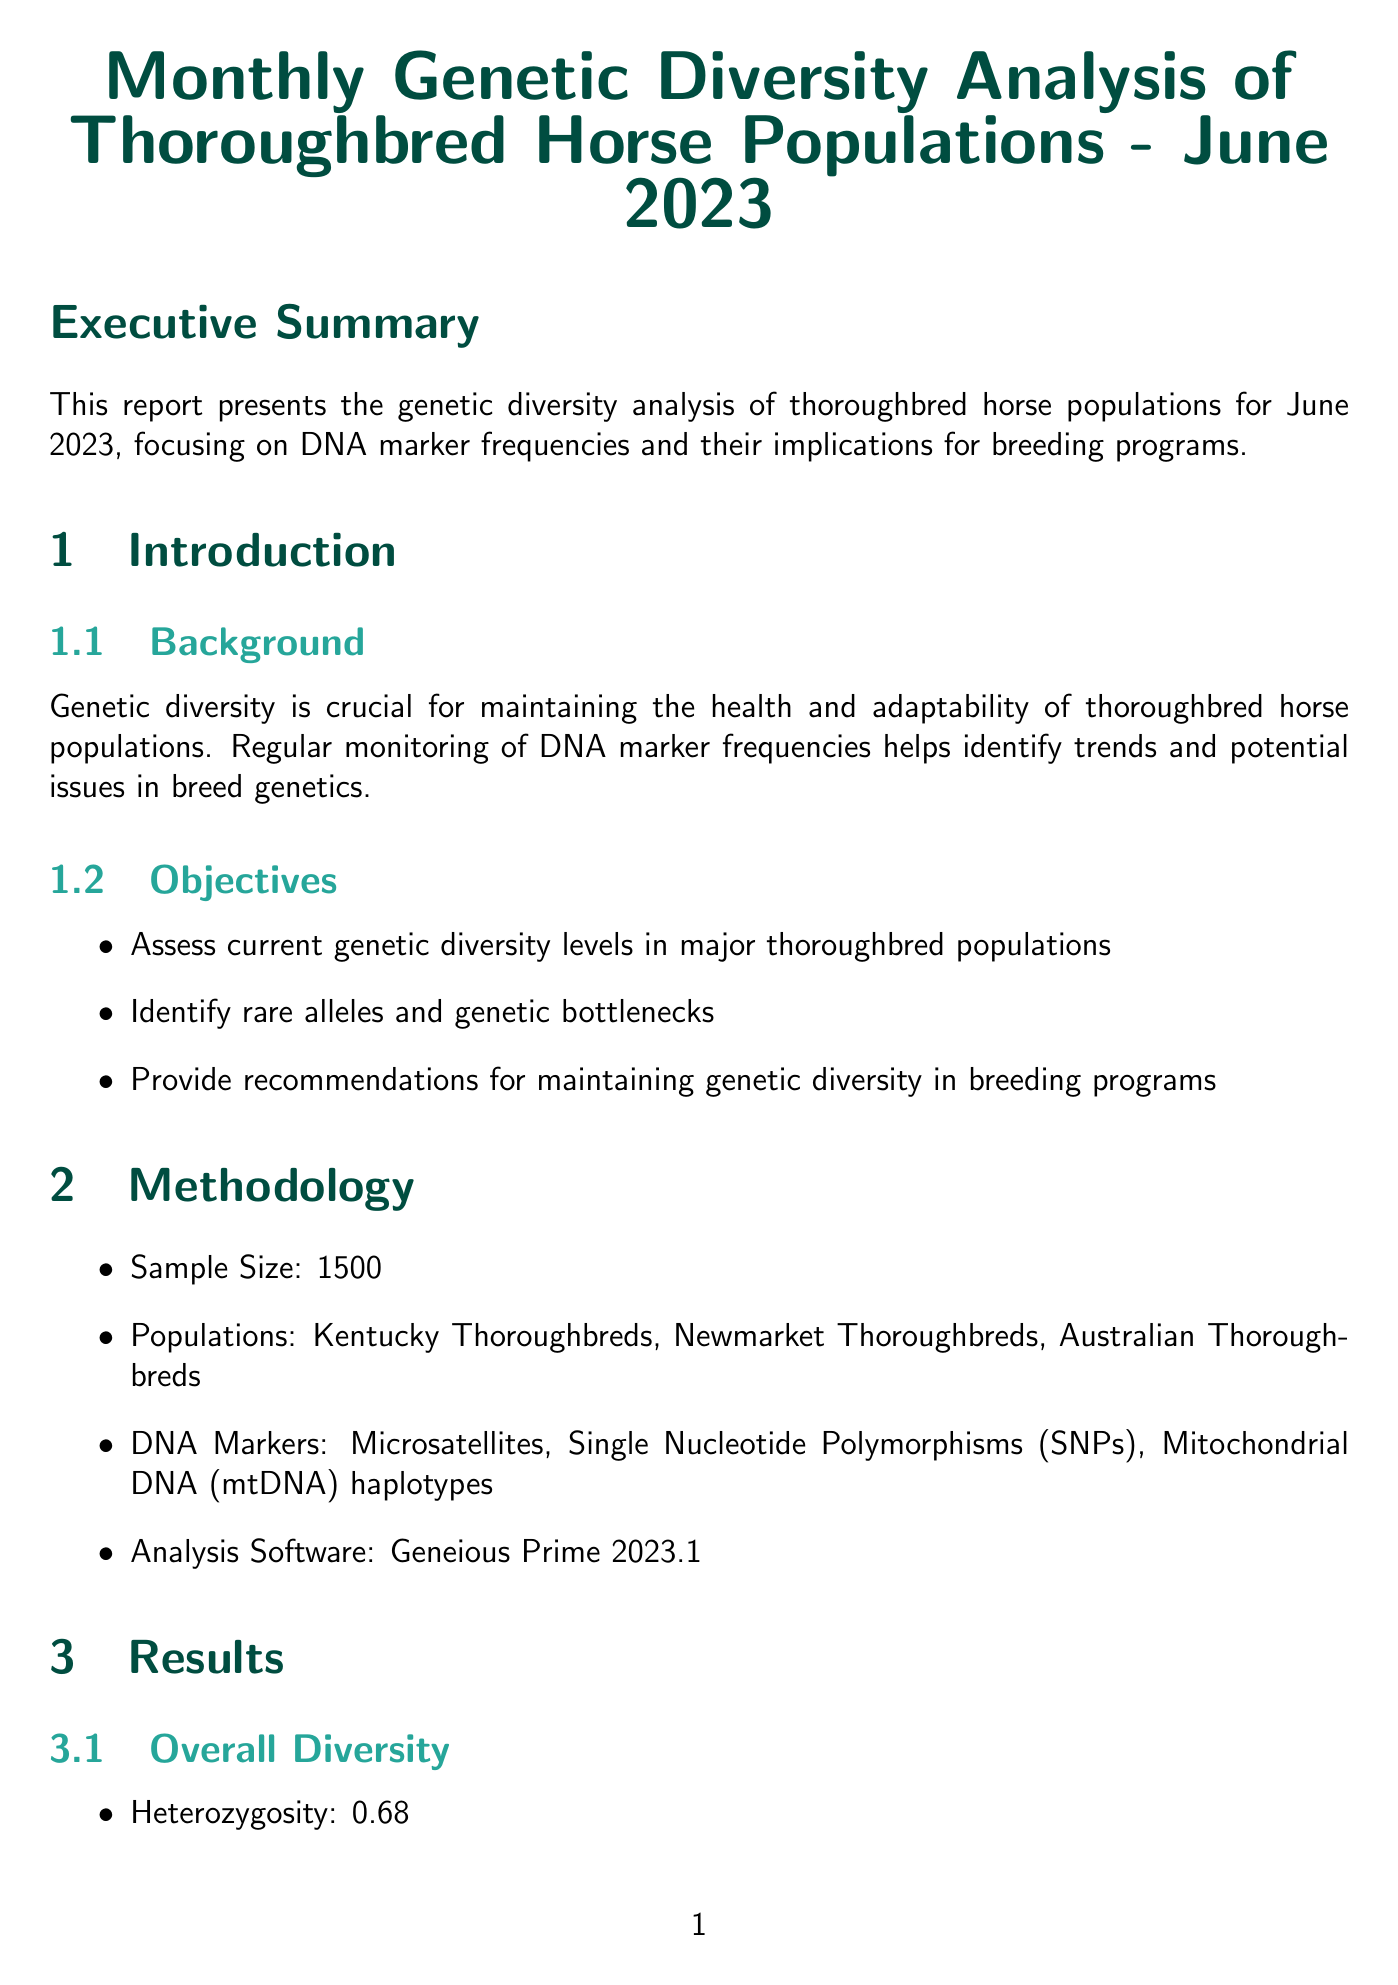What is the sample size of the analysis? The sample size is specified in the methodology section, which states that 1500 horses were sampled for the analysis.
Answer: 1500 What are the three populations analyzed? The populations are listed under the methodology section, where Kentucky Thoroughbreds, Newmarket Thoroughbreds, and Australian Thoroughbreds are mentioned.
Answer: Kentucky Thoroughbreds, Newmarket Thoroughbreds, Australian Thoroughbreds What is the heterozygosity level reported? The overall diversity section reveals that the heterozygosity level is a crucial metric, which is stated as 0.68.
Answer: 0.68 Which thoroughbred population has the highest unique alleles? The population comparisons section indicates that the Australian Thoroughbreds have the highest unique alleles, being noted with a count of 15.
Answer: Australian Thoroughbreds What is the frequency of the rare allele AHT4? The rare alleles section provides frequencies for specific alleles, with the frequency of AHT4 listed as 0.003.
Answer: 0.003 What recommendation is made for the Australian population? The recommendations section highlights targeted breeding strategies to maintain rare alleles, emphasizing actions needed specifically for the Australian population.
Answer: Implement targeted breeding strategies How does the inbreeding coefficient change from the previous analysis? The discussion points note a slight increase in the inbreeding coefficient compared to the last month, mentioning a current figure of 0.023.
Answer: Increase What is the significance of "Galileo's Legacy"? The significant pedigrees section indicates that Galileo's Legacy carries multiple rare alleles and has high breeding value for maintaining genetic diversity, showcasing its importance in the genetic landscape.
Answer: Carries multiple rare alleles What type of visual representation shows genetic relationships among populations? The visualizations section describes a Principal Component Analysis (PCA) plot that visually represents genetic distances among the populations studied based on DNA marker data.
Answer: PCA Plot 